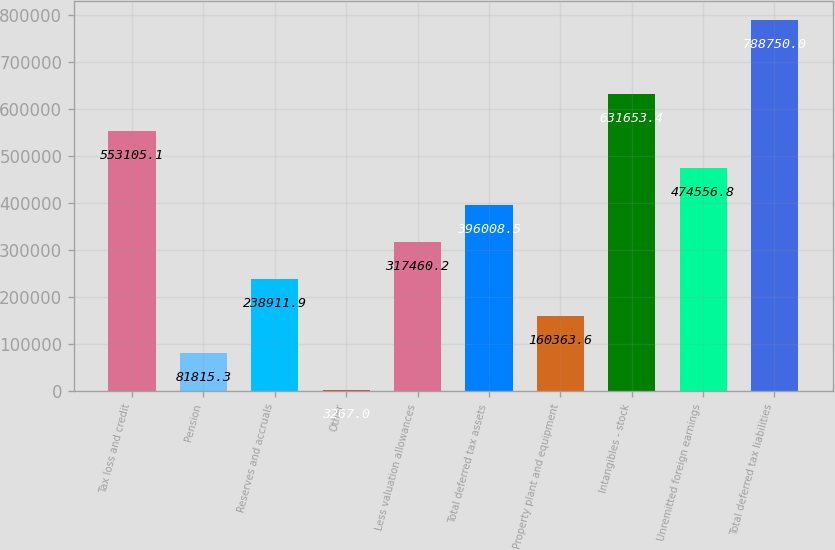<chart> <loc_0><loc_0><loc_500><loc_500><bar_chart><fcel>Tax loss and credit<fcel>Pension<fcel>Reserves and accruals<fcel>Other<fcel>Less valuation allowances<fcel>Total deferred tax assets<fcel>Property plant and equipment<fcel>Intangibles - stock<fcel>Unremitted foreign earnings<fcel>Total deferred tax liabilities<nl><fcel>553105<fcel>81815.3<fcel>238912<fcel>3267<fcel>317460<fcel>396008<fcel>160364<fcel>631653<fcel>474557<fcel>788750<nl></chart> 